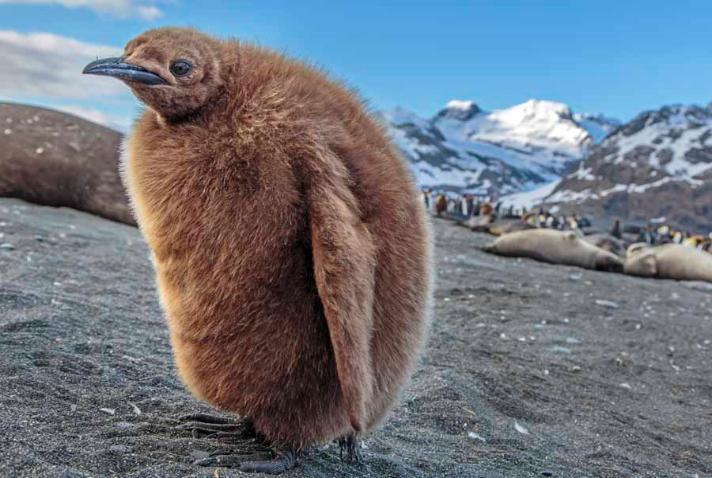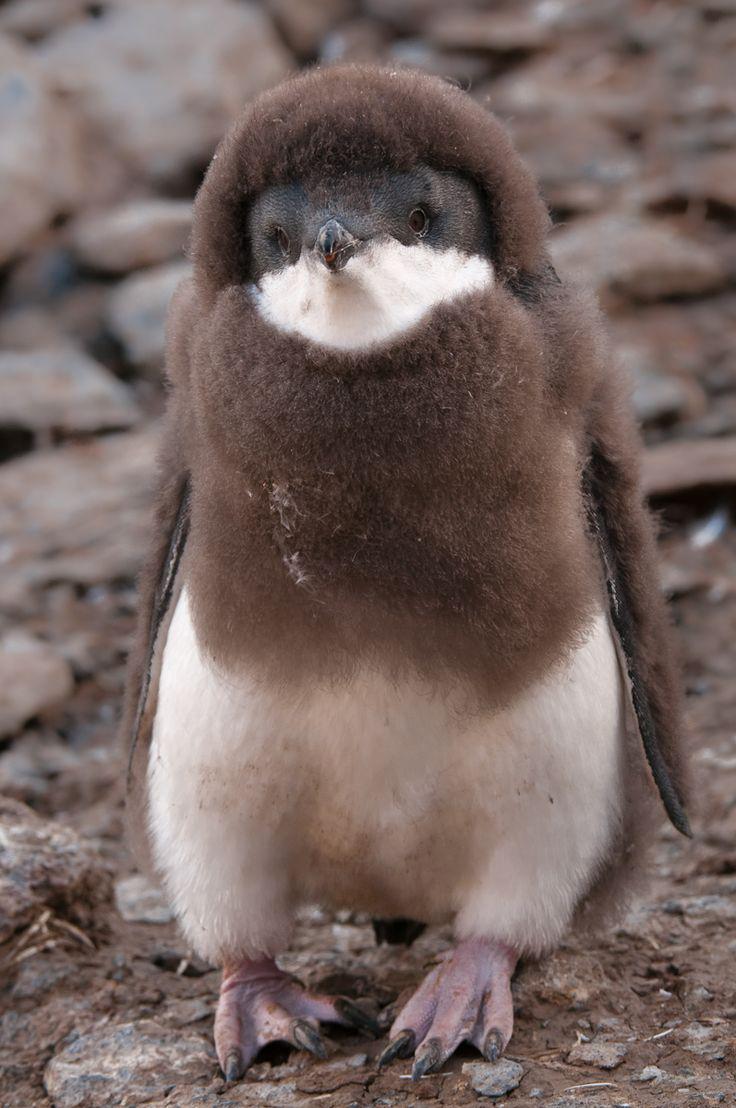The first image is the image on the left, the second image is the image on the right. Assess this claim about the two images: "The right image shows a very young fuzzy penguin with some white on its face.". Correct or not? Answer yes or no. Yes. 